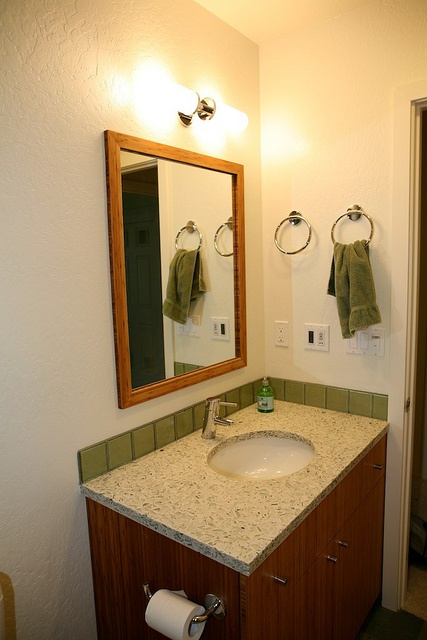Describe the objects in this image and their specific colors. I can see a sink in olive and tan tones in this image. 